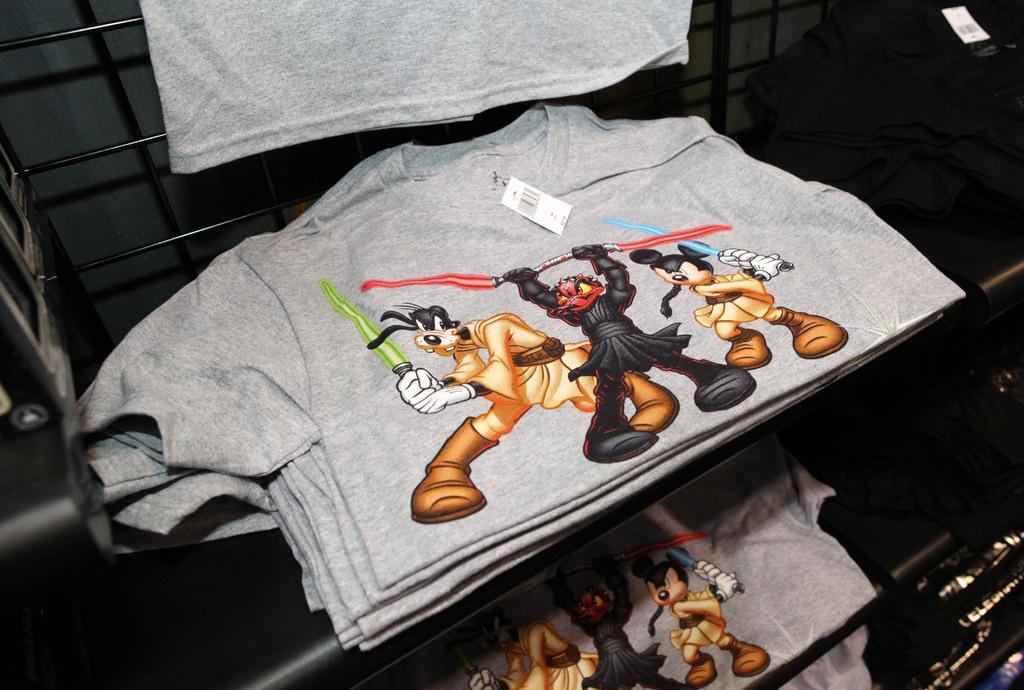In one or two sentences, can you explain what this image depicts? In this image I can see grey t shirts in the racks. There are cartoon prints on the t shirts. 